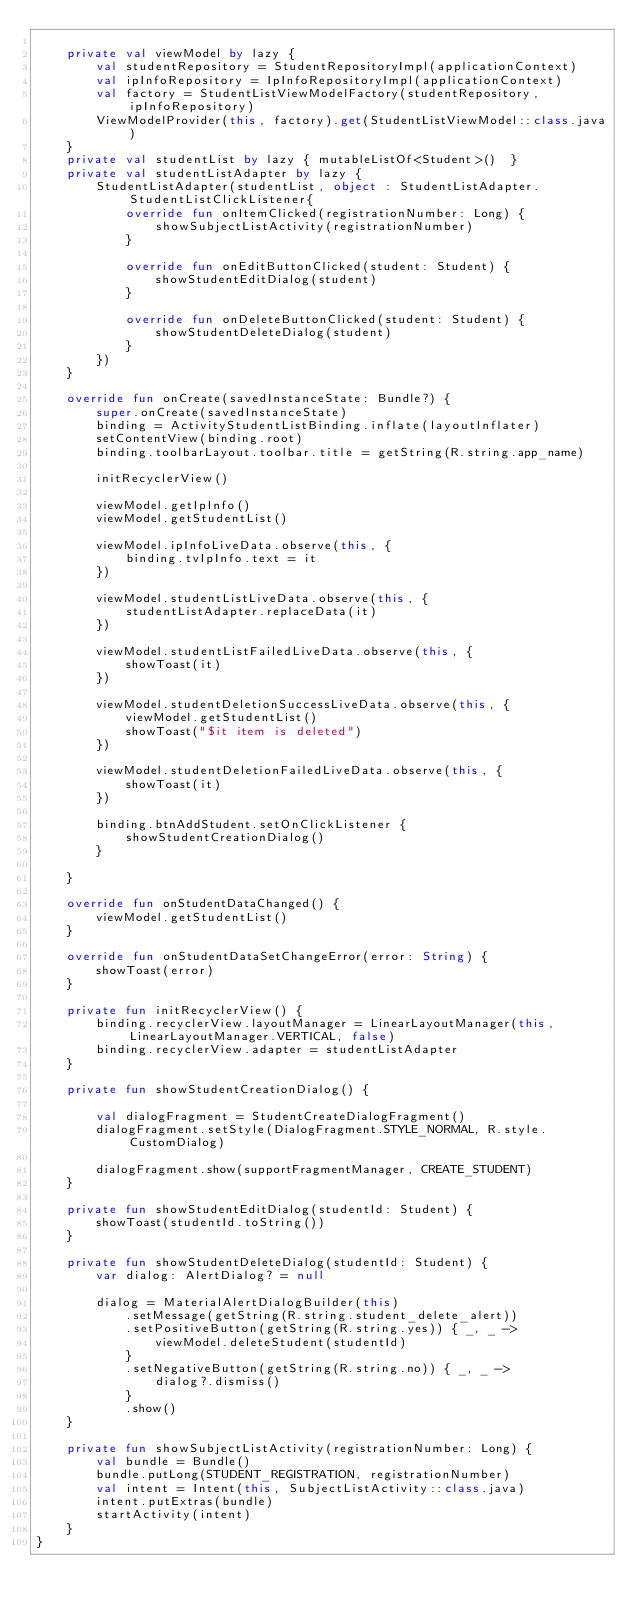Convert code to text. <code><loc_0><loc_0><loc_500><loc_500><_Kotlin_>
    private val viewModel by lazy {
        val studentRepository = StudentRepositoryImpl(applicationContext)
        val ipInfoRepository = IpInfoRepositoryImpl(applicationContext)
        val factory = StudentListViewModelFactory(studentRepository, ipInfoRepository)
        ViewModelProvider(this, factory).get(StudentListViewModel::class.java)
    }
    private val studentList by lazy { mutableListOf<Student>()  }
    private val studentListAdapter by lazy {
        StudentListAdapter(studentList, object : StudentListAdapter.StudentListClickListener{
            override fun onItemClicked(registrationNumber: Long) {
                showSubjectListActivity(registrationNumber)
            }

            override fun onEditButtonClicked(student: Student) {
                showStudentEditDialog(student)
            }

            override fun onDeleteButtonClicked(student: Student) {
                showStudentDeleteDialog(student)
            }
        })
    }

    override fun onCreate(savedInstanceState: Bundle?) {
        super.onCreate(savedInstanceState)
        binding = ActivityStudentListBinding.inflate(layoutInflater)
        setContentView(binding.root)
        binding.toolbarLayout.toolbar.title = getString(R.string.app_name)

        initRecyclerView()

        viewModel.getIpInfo()
        viewModel.getStudentList()

        viewModel.ipInfoLiveData.observe(this, {
            binding.tvIpInfo.text = it
        })

        viewModel.studentListLiveData.observe(this, {
            studentListAdapter.replaceData(it)
        })

        viewModel.studentListFailedLiveData.observe(this, {
            showToast(it)
        })

        viewModel.studentDeletionSuccessLiveData.observe(this, {
            viewModel.getStudentList()
            showToast("$it item is deleted")
        })

        viewModel.studentDeletionFailedLiveData.observe(this, {
            showToast(it)
        })

        binding.btnAddStudent.setOnClickListener {
            showStudentCreationDialog()
        }

    }

    override fun onStudentDataChanged() {
        viewModel.getStudentList()
    }

    override fun onStudentDataSetChangeError(error: String) {
        showToast(error)
    }

    private fun initRecyclerView() {
        binding.recyclerView.layoutManager = LinearLayoutManager(this, LinearLayoutManager.VERTICAL, false)
        binding.recyclerView.adapter = studentListAdapter
    }

    private fun showStudentCreationDialog() {

        val dialogFragment = StudentCreateDialogFragment()
        dialogFragment.setStyle(DialogFragment.STYLE_NORMAL, R.style.CustomDialog)

        dialogFragment.show(supportFragmentManager, CREATE_STUDENT)
    }

    private fun showStudentEditDialog(studentId: Student) {
        showToast(studentId.toString())
    }

    private fun showStudentDeleteDialog(studentId: Student) {
        var dialog: AlertDialog? = null

        dialog = MaterialAlertDialogBuilder(this)
            .setMessage(getString(R.string.student_delete_alert))
            .setPositiveButton(getString(R.string.yes)) { _, _ ->
                viewModel.deleteStudent(studentId)
            }
            .setNegativeButton(getString(R.string.no)) { _, _ ->
                dialog?.dismiss()
            }
            .show()
    }

    private fun showSubjectListActivity(registrationNumber: Long) {
        val bundle = Bundle()
        bundle.putLong(STUDENT_REGISTRATION, registrationNumber)
        val intent = Intent(this, SubjectListActivity::class.java)
        intent.putExtras(bundle)
        startActivity(intent)
    }
}</code> 